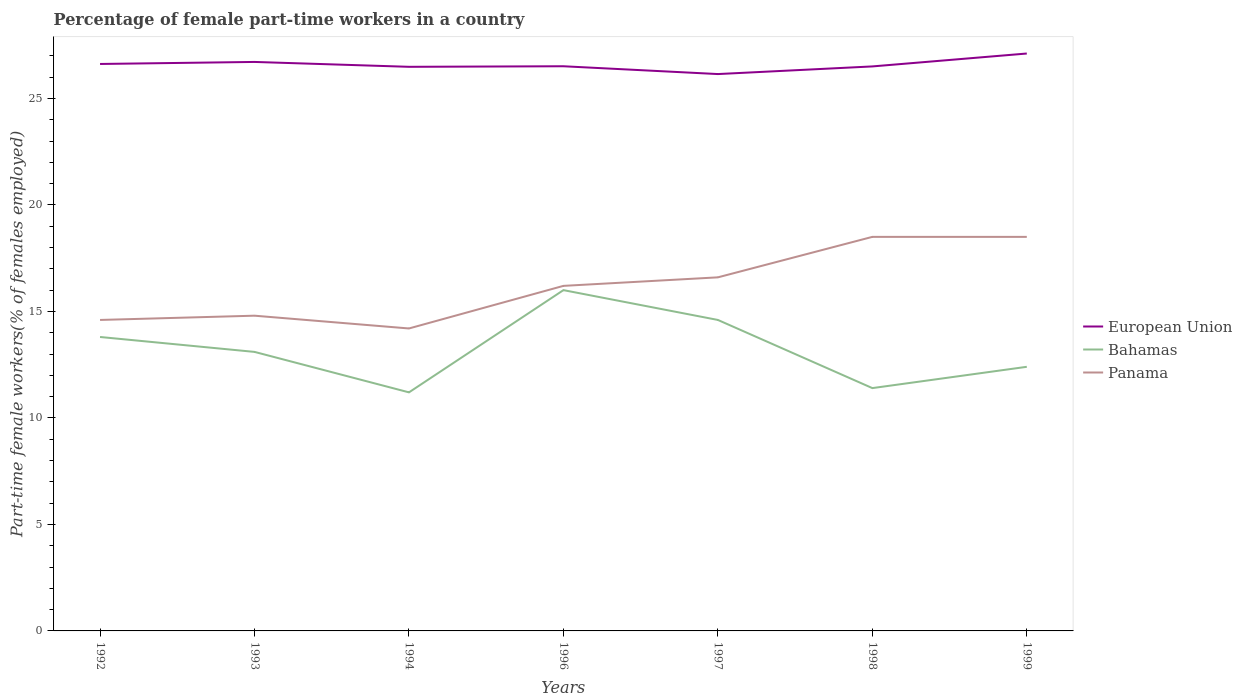How many different coloured lines are there?
Your response must be concise. 3. Across all years, what is the maximum percentage of female part-time workers in European Union?
Your answer should be compact. 26.14. What is the total percentage of female part-time workers in Panama in the graph?
Ensure brevity in your answer.  0.6. What is the difference between the highest and the second highest percentage of female part-time workers in Bahamas?
Offer a very short reply. 4.8. Is the percentage of female part-time workers in European Union strictly greater than the percentage of female part-time workers in Bahamas over the years?
Provide a short and direct response. No. How many lines are there?
Provide a succinct answer. 3. What is the difference between two consecutive major ticks on the Y-axis?
Offer a terse response. 5. Are the values on the major ticks of Y-axis written in scientific E-notation?
Provide a succinct answer. No. Does the graph contain any zero values?
Keep it short and to the point. No. Where does the legend appear in the graph?
Your answer should be very brief. Center right. How many legend labels are there?
Your response must be concise. 3. What is the title of the graph?
Offer a terse response. Percentage of female part-time workers in a country. What is the label or title of the X-axis?
Offer a very short reply. Years. What is the label or title of the Y-axis?
Your answer should be compact. Part-time female workers(% of females employed). What is the Part-time female workers(% of females employed) of European Union in 1992?
Provide a succinct answer. 26.62. What is the Part-time female workers(% of females employed) of Bahamas in 1992?
Offer a terse response. 13.8. What is the Part-time female workers(% of females employed) in Panama in 1992?
Provide a succinct answer. 14.6. What is the Part-time female workers(% of females employed) in European Union in 1993?
Make the answer very short. 26.71. What is the Part-time female workers(% of females employed) in Bahamas in 1993?
Your answer should be very brief. 13.1. What is the Part-time female workers(% of females employed) in Panama in 1993?
Your answer should be compact. 14.8. What is the Part-time female workers(% of females employed) in European Union in 1994?
Offer a very short reply. 26.48. What is the Part-time female workers(% of females employed) in Bahamas in 1994?
Give a very brief answer. 11.2. What is the Part-time female workers(% of females employed) in Panama in 1994?
Make the answer very short. 14.2. What is the Part-time female workers(% of females employed) of European Union in 1996?
Give a very brief answer. 26.51. What is the Part-time female workers(% of females employed) in Bahamas in 1996?
Your answer should be very brief. 16. What is the Part-time female workers(% of females employed) in Panama in 1996?
Provide a short and direct response. 16.2. What is the Part-time female workers(% of females employed) in European Union in 1997?
Offer a very short reply. 26.14. What is the Part-time female workers(% of females employed) in Bahamas in 1997?
Offer a terse response. 14.6. What is the Part-time female workers(% of females employed) in Panama in 1997?
Provide a succinct answer. 16.6. What is the Part-time female workers(% of females employed) of European Union in 1998?
Your answer should be compact. 26.5. What is the Part-time female workers(% of females employed) in Bahamas in 1998?
Your answer should be very brief. 11.4. What is the Part-time female workers(% of females employed) of European Union in 1999?
Offer a terse response. 27.11. What is the Part-time female workers(% of females employed) in Bahamas in 1999?
Give a very brief answer. 12.4. Across all years, what is the maximum Part-time female workers(% of females employed) in European Union?
Your response must be concise. 27.11. Across all years, what is the maximum Part-time female workers(% of females employed) of Panama?
Give a very brief answer. 18.5. Across all years, what is the minimum Part-time female workers(% of females employed) of European Union?
Ensure brevity in your answer.  26.14. Across all years, what is the minimum Part-time female workers(% of females employed) in Bahamas?
Your answer should be compact. 11.2. Across all years, what is the minimum Part-time female workers(% of females employed) of Panama?
Offer a terse response. 14.2. What is the total Part-time female workers(% of females employed) of European Union in the graph?
Give a very brief answer. 186.08. What is the total Part-time female workers(% of females employed) of Bahamas in the graph?
Keep it short and to the point. 92.5. What is the total Part-time female workers(% of females employed) in Panama in the graph?
Give a very brief answer. 113.4. What is the difference between the Part-time female workers(% of females employed) of European Union in 1992 and that in 1993?
Provide a short and direct response. -0.1. What is the difference between the Part-time female workers(% of females employed) in Bahamas in 1992 and that in 1993?
Provide a short and direct response. 0.7. What is the difference between the Part-time female workers(% of females employed) in European Union in 1992 and that in 1994?
Keep it short and to the point. 0.13. What is the difference between the Part-time female workers(% of females employed) in Bahamas in 1992 and that in 1994?
Offer a very short reply. 2.6. What is the difference between the Part-time female workers(% of females employed) of Panama in 1992 and that in 1994?
Your answer should be very brief. 0.4. What is the difference between the Part-time female workers(% of females employed) in European Union in 1992 and that in 1996?
Offer a very short reply. 0.11. What is the difference between the Part-time female workers(% of females employed) of European Union in 1992 and that in 1997?
Give a very brief answer. 0.47. What is the difference between the Part-time female workers(% of females employed) of Bahamas in 1992 and that in 1997?
Keep it short and to the point. -0.8. What is the difference between the Part-time female workers(% of females employed) in Panama in 1992 and that in 1997?
Your response must be concise. -2. What is the difference between the Part-time female workers(% of females employed) in European Union in 1992 and that in 1998?
Give a very brief answer. 0.12. What is the difference between the Part-time female workers(% of females employed) of Panama in 1992 and that in 1998?
Keep it short and to the point. -3.9. What is the difference between the Part-time female workers(% of females employed) in European Union in 1992 and that in 1999?
Your answer should be compact. -0.49. What is the difference between the Part-time female workers(% of females employed) of Bahamas in 1992 and that in 1999?
Your response must be concise. 1.4. What is the difference between the Part-time female workers(% of females employed) of European Union in 1993 and that in 1994?
Offer a very short reply. 0.23. What is the difference between the Part-time female workers(% of females employed) in European Union in 1993 and that in 1996?
Make the answer very short. 0.2. What is the difference between the Part-time female workers(% of females employed) of Bahamas in 1993 and that in 1996?
Make the answer very short. -2.9. What is the difference between the Part-time female workers(% of females employed) in European Union in 1993 and that in 1997?
Your answer should be compact. 0.57. What is the difference between the Part-time female workers(% of females employed) of European Union in 1993 and that in 1998?
Your answer should be very brief. 0.21. What is the difference between the Part-time female workers(% of females employed) in Panama in 1993 and that in 1998?
Give a very brief answer. -3.7. What is the difference between the Part-time female workers(% of females employed) in European Union in 1993 and that in 1999?
Your answer should be compact. -0.4. What is the difference between the Part-time female workers(% of females employed) of European Union in 1994 and that in 1996?
Your response must be concise. -0.03. What is the difference between the Part-time female workers(% of females employed) of European Union in 1994 and that in 1997?
Give a very brief answer. 0.34. What is the difference between the Part-time female workers(% of females employed) of Panama in 1994 and that in 1997?
Keep it short and to the point. -2.4. What is the difference between the Part-time female workers(% of females employed) in European Union in 1994 and that in 1998?
Your answer should be very brief. -0.02. What is the difference between the Part-time female workers(% of females employed) in Bahamas in 1994 and that in 1998?
Offer a very short reply. -0.2. What is the difference between the Part-time female workers(% of females employed) in European Union in 1994 and that in 1999?
Provide a succinct answer. -0.62. What is the difference between the Part-time female workers(% of females employed) in European Union in 1996 and that in 1997?
Make the answer very short. 0.37. What is the difference between the Part-time female workers(% of females employed) of Bahamas in 1996 and that in 1997?
Ensure brevity in your answer.  1.4. What is the difference between the Part-time female workers(% of females employed) in Panama in 1996 and that in 1997?
Your answer should be compact. -0.4. What is the difference between the Part-time female workers(% of females employed) in European Union in 1996 and that in 1998?
Your answer should be very brief. 0.01. What is the difference between the Part-time female workers(% of females employed) in European Union in 1996 and that in 1999?
Keep it short and to the point. -0.6. What is the difference between the Part-time female workers(% of females employed) in Bahamas in 1996 and that in 1999?
Keep it short and to the point. 3.6. What is the difference between the Part-time female workers(% of females employed) in European Union in 1997 and that in 1998?
Your answer should be compact. -0.36. What is the difference between the Part-time female workers(% of females employed) of Bahamas in 1997 and that in 1998?
Your answer should be compact. 3.2. What is the difference between the Part-time female workers(% of females employed) of Panama in 1997 and that in 1998?
Keep it short and to the point. -1.9. What is the difference between the Part-time female workers(% of females employed) in European Union in 1997 and that in 1999?
Make the answer very short. -0.96. What is the difference between the Part-time female workers(% of females employed) of Bahamas in 1997 and that in 1999?
Your answer should be compact. 2.2. What is the difference between the Part-time female workers(% of females employed) of European Union in 1998 and that in 1999?
Offer a terse response. -0.61. What is the difference between the Part-time female workers(% of females employed) of Panama in 1998 and that in 1999?
Offer a terse response. 0. What is the difference between the Part-time female workers(% of females employed) of European Union in 1992 and the Part-time female workers(% of females employed) of Bahamas in 1993?
Make the answer very short. 13.52. What is the difference between the Part-time female workers(% of females employed) in European Union in 1992 and the Part-time female workers(% of females employed) in Panama in 1993?
Give a very brief answer. 11.82. What is the difference between the Part-time female workers(% of females employed) in Bahamas in 1992 and the Part-time female workers(% of females employed) in Panama in 1993?
Provide a short and direct response. -1. What is the difference between the Part-time female workers(% of females employed) in European Union in 1992 and the Part-time female workers(% of females employed) in Bahamas in 1994?
Your answer should be very brief. 15.42. What is the difference between the Part-time female workers(% of females employed) in European Union in 1992 and the Part-time female workers(% of females employed) in Panama in 1994?
Keep it short and to the point. 12.42. What is the difference between the Part-time female workers(% of females employed) of European Union in 1992 and the Part-time female workers(% of females employed) of Bahamas in 1996?
Provide a short and direct response. 10.62. What is the difference between the Part-time female workers(% of females employed) of European Union in 1992 and the Part-time female workers(% of females employed) of Panama in 1996?
Your answer should be compact. 10.42. What is the difference between the Part-time female workers(% of females employed) in European Union in 1992 and the Part-time female workers(% of females employed) in Bahamas in 1997?
Ensure brevity in your answer.  12.02. What is the difference between the Part-time female workers(% of females employed) of European Union in 1992 and the Part-time female workers(% of females employed) of Panama in 1997?
Offer a very short reply. 10.02. What is the difference between the Part-time female workers(% of females employed) in European Union in 1992 and the Part-time female workers(% of females employed) in Bahamas in 1998?
Your answer should be compact. 15.22. What is the difference between the Part-time female workers(% of females employed) of European Union in 1992 and the Part-time female workers(% of females employed) of Panama in 1998?
Your answer should be very brief. 8.12. What is the difference between the Part-time female workers(% of females employed) of Bahamas in 1992 and the Part-time female workers(% of females employed) of Panama in 1998?
Your answer should be compact. -4.7. What is the difference between the Part-time female workers(% of females employed) of European Union in 1992 and the Part-time female workers(% of females employed) of Bahamas in 1999?
Your answer should be very brief. 14.22. What is the difference between the Part-time female workers(% of females employed) of European Union in 1992 and the Part-time female workers(% of females employed) of Panama in 1999?
Offer a terse response. 8.12. What is the difference between the Part-time female workers(% of females employed) of Bahamas in 1992 and the Part-time female workers(% of females employed) of Panama in 1999?
Offer a terse response. -4.7. What is the difference between the Part-time female workers(% of females employed) in European Union in 1993 and the Part-time female workers(% of females employed) in Bahamas in 1994?
Provide a succinct answer. 15.51. What is the difference between the Part-time female workers(% of females employed) of European Union in 1993 and the Part-time female workers(% of females employed) of Panama in 1994?
Your response must be concise. 12.51. What is the difference between the Part-time female workers(% of females employed) of Bahamas in 1993 and the Part-time female workers(% of females employed) of Panama in 1994?
Your answer should be very brief. -1.1. What is the difference between the Part-time female workers(% of females employed) in European Union in 1993 and the Part-time female workers(% of females employed) in Bahamas in 1996?
Your answer should be very brief. 10.71. What is the difference between the Part-time female workers(% of females employed) of European Union in 1993 and the Part-time female workers(% of females employed) of Panama in 1996?
Your answer should be very brief. 10.51. What is the difference between the Part-time female workers(% of females employed) in European Union in 1993 and the Part-time female workers(% of females employed) in Bahamas in 1997?
Ensure brevity in your answer.  12.11. What is the difference between the Part-time female workers(% of females employed) of European Union in 1993 and the Part-time female workers(% of females employed) of Panama in 1997?
Give a very brief answer. 10.11. What is the difference between the Part-time female workers(% of females employed) in European Union in 1993 and the Part-time female workers(% of females employed) in Bahamas in 1998?
Offer a very short reply. 15.31. What is the difference between the Part-time female workers(% of females employed) in European Union in 1993 and the Part-time female workers(% of females employed) in Panama in 1998?
Ensure brevity in your answer.  8.21. What is the difference between the Part-time female workers(% of females employed) in Bahamas in 1993 and the Part-time female workers(% of females employed) in Panama in 1998?
Your response must be concise. -5.4. What is the difference between the Part-time female workers(% of females employed) in European Union in 1993 and the Part-time female workers(% of females employed) in Bahamas in 1999?
Give a very brief answer. 14.31. What is the difference between the Part-time female workers(% of females employed) in European Union in 1993 and the Part-time female workers(% of females employed) in Panama in 1999?
Your response must be concise. 8.21. What is the difference between the Part-time female workers(% of females employed) of European Union in 1994 and the Part-time female workers(% of females employed) of Bahamas in 1996?
Your answer should be compact. 10.48. What is the difference between the Part-time female workers(% of females employed) of European Union in 1994 and the Part-time female workers(% of females employed) of Panama in 1996?
Keep it short and to the point. 10.28. What is the difference between the Part-time female workers(% of females employed) in European Union in 1994 and the Part-time female workers(% of females employed) in Bahamas in 1997?
Provide a succinct answer. 11.88. What is the difference between the Part-time female workers(% of females employed) in European Union in 1994 and the Part-time female workers(% of females employed) in Panama in 1997?
Make the answer very short. 9.88. What is the difference between the Part-time female workers(% of females employed) in Bahamas in 1994 and the Part-time female workers(% of females employed) in Panama in 1997?
Your response must be concise. -5.4. What is the difference between the Part-time female workers(% of females employed) of European Union in 1994 and the Part-time female workers(% of females employed) of Bahamas in 1998?
Offer a terse response. 15.08. What is the difference between the Part-time female workers(% of females employed) in European Union in 1994 and the Part-time female workers(% of females employed) in Panama in 1998?
Your answer should be very brief. 7.98. What is the difference between the Part-time female workers(% of females employed) of European Union in 1994 and the Part-time female workers(% of females employed) of Bahamas in 1999?
Keep it short and to the point. 14.08. What is the difference between the Part-time female workers(% of females employed) in European Union in 1994 and the Part-time female workers(% of females employed) in Panama in 1999?
Provide a short and direct response. 7.98. What is the difference between the Part-time female workers(% of females employed) in European Union in 1996 and the Part-time female workers(% of females employed) in Bahamas in 1997?
Offer a very short reply. 11.91. What is the difference between the Part-time female workers(% of females employed) in European Union in 1996 and the Part-time female workers(% of females employed) in Panama in 1997?
Give a very brief answer. 9.91. What is the difference between the Part-time female workers(% of females employed) of Bahamas in 1996 and the Part-time female workers(% of females employed) of Panama in 1997?
Ensure brevity in your answer.  -0.6. What is the difference between the Part-time female workers(% of females employed) of European Union in 1996 and the Part-time female workers(% of females employed) of Bahamas in 1998?
Your response must be concise. 15.11. What is the difference between the Part-time female workers(% of females employed) of European Union in 1996 and the Part-time female workers(% of females employed) of Panama in 1998?
Offer a very short reply. 8.01. What is the difference between the Part-time female workers(% of females employed) in European Union in 1996 and the Part-time female workers(% of females employed) in Bahamas in 1999?
Keep it short and to the point. 14.11. What is the difference between the Part-time female workers(% of females employed) of European Union in 1996 and the Part-time female workers(% of females employed) of Panama in 1999?
Provide a short and direct response. 8.01. What is the difference between the Part-time female workers(% of females employed) in European Union in 1997 and the Part-time female workers(% of females employed) in Bahamas in 1998?
Provide a succinct answer. 14.74. What is the difference between the Part-time female workers(% of females employed) of European Union in 1997 and the Part-time female workers(% of females employed) of Panama in 1998?
Give a very brief answer. 7.64. What is the difference between the Part-time female workers(% of females employed) in European Union in 1997 and the Part-time female workers(% of females employed) in Bahamas in 1999?
Keep it short and to the point. 13.74. What is the difference between the Part-time female workers(% of females employed) in European Union in 1997 and the Part-time female workers(% of females employed) in Panama in 1999?
Make the answer very short. 7.64. What is the difference between the Part-time female workers(% of females employed) in European Union in 1998 and the Part-time female workers(% of females employed) in Bahamas in 1999?
Make the answer very short. 14.1. What is the difference between the Part-time female workers(% of females employed) in European Union in 1998 and the Part-time female workers(% of females employed) in Panama in 1999?
Make the answer very short. 8. What is the average Part-time female workers(% of females employed) in European Union per year?
Offer a very short reply. 26.58. What is the average Part-time female workers(% of females employed) of Bahamas per year?
Offer a very short reply. 13.21. What is the average Part-time female workers(% of females employed) of Panama per year?
Keep it short and to the point. 16.2. In the year 1992, what is the difference between the Part-time female workers(% of females employed) in European Union and Part-time female workers(% of females employed) in Bahamas?
Provide a short and direct response. 12.82. In the year 1992, what is the difference between the Part-time female workers(% of females employed) of European Union and Part-time female workers(% of females employed) of Panama?
Ensure brevity in your answer.  12.02. In the year 1992, what is the difference between the Part-time female workers(% of females employed) of Bahamas and Part-time female workers(% of females employed) of Panama?
Provide a short and direct response. -0.8. In the year 1993, what is the difference between the Part-time female workers(% of females employed) of European Union and Part-time female workers(% of females employed) of Bahamas?
Give a very brief answer. 13.61. In the year 1993, what is the difference between the Part-time female workers(% of females employed) of European Union and Part-time female workers(% of females employed) of Panama?
Offer a terse response. 11.91. In the year 1994, what is the difference between the Part-time female workers(% of females employed) of European Union and Part-time female workers(% of females employed) of Bahamas?
Provide a succinct answer. 15.28. In the year 1994, what is the difference between the Part-time female workers(% of females employed) in European Union and Part-time female workers(% of females employed) in Panama?
Ensure brevity in your answer.  12.28. In the year 1996, what is the difference between the Part-time female workers(% of females employed) in European Union and Part-time female workers(% of females employed) in Bahamas?
Ensure brevity in your answer.  10.51. In the year 1996, what is the difference between the Part-time female workers(% of females employed) in European Union and Part-time female workers(% of females employed) in Panama?
Your answer should be very brief. 10.31. In the year 1996, what is the difference between the Part-time female workers(% of females employed) of Bahamas and Part-time female workers(% of females employed) of Panama?
Ensure brevity in your answer.  -0.2. In the year 1997, what is the difference between the Part-time female workers(% of females employed) of European Union and Part-time female workers(% of females employed) of Bahamas?
Ensure brevity in your answer.  11.54. In the year 1997, what is the difference between the Part-time female workers(% of females employed) in European Union and Part-time female workers(% of females employed) in Panama?
Offer a very short reply. 9.54. In the year 1997, what is the difference between the Part-time female workers(% of females employed) in Bahamas and Part-time female workers(% of females employed) in Panama?
Offer a very short reply. -2. In the year 1998, what is the difference between the Part-time female workers(% of females employed) of European Union and Part-time female workers(% of females employed) of Bahamas?
Offer a very short reply. 15.1. In the year 1998, what is the difference between the Part-time female workers(% of females employed) of European Union and Part-time female workers(% of females employed) of Panama?
Your response must be concise. 8. In the year 1999, what is the difference between the Part-time female workers(% of females employed) of European Union and Part-time female workers(% of females employed) of Bahamas?
Provide a succinct answer. 14.71. In the year 1999, what is the difference between the Part-time female workers(% of females employed) of European Union and Part-time female workers(% of females employed) of Panama?
Your answer should be very brief. 8.61. In the year 1999, what is the difference between the Part-time female workers(% of females employed) of Bahamas and Part-time female workers(% of females employed) of Panama?
Ensure brevity in your answer.  -6.1. What is the ratio of the Part-time female workers(% of females employed) in European Union in 1992 to that in 1993?
Give a very brief answer. 1. What is the ratio of the Part-time female workers(% of females employed) of Bahamas in 1992 to that in 1993?
Keep it short and to the point. 1.05. What is the ratio of the Part-time female workers(% of females employed) in Panama in 1992 to that in 1993?
Keep it short and to the point. 0.99. What is the ratio of the Part-time female workers(% of females employed) in Bahamas in 1992 to that in 1994?
Provide a succinct answer. 1.23. What is the ratio of the Part-time female workers(% of females employed) in Panama in 1992 to that in 1994?
Provide a succinct answer. 1.03. What is the ratio of the Part-time female workers(% of females employed) of Bahamas in 1992 to that in 1996?
Give a very brief answer. 0.86. What is the ratio of the Part-time female workers(% of females employed) in Panama in 1992 to that in 1996?
Your answer should be very brief. 0.9. What is the ratio of the Part-time female workers(% of females employed) of European Union in 1992 to that in 1997?
Ensure brevity in your answer.  1.02. What is the ratio of the Part-time female workers(% of females employed) of Bahamas in 1992 to that in 1997?
Your answer should be compact. 0.95. What is the ratio of the Part-time female workers(% of females employed) of Panama in 1992 to that in 1997?
Your answer should be compact. 0.88. What is the ratio of the Part-time female workers(% of females employed) of European Union in 1992 to that in 1998?
Offer a terse response. 1. What is the ratio of the Part-time female workers(% of females employed) of Bahamas in 1992 to that in 1998?
Provide a succinct answer. 1.21. What is the ratio of the Part-time female workers(% of females employed) in Panama in 1992 to that in 1998?
Your answer should be compact. 0.79. What is the ratio of the Part-time female workers(% of females employed) in European Union in 1992 to that in 1999?
Give a very brief answer. 0.98. What is the ratio of the Part-time female workers(% of females employed) of Bahamas in 1992 to that in 1999?
Provide a short and direct response. 1.11. What is the ratio of the Part-time female workers(% of females employed) in Panama in 1992 to that in 1999?
Your answer should be very brief. 0.79. What is the ratio of the Part-time female workers(% of females employed) of European Union in 1993 to that in 1994?
Your answer should be compact. 1.01. What is the ratio of the Part-time female workers(% of females employed) in Bahamas in 1993 to that in 1994?
Offer a very short reply. 1.17. What is the ratio of the Part-time female workers(% of females employed) in Panama in 1993 to that in 1994?
Give a very brief answer. 1.04. What is the ratio of the Part-time female workers(% of females employed) in European Union in 1993 to that in 1996?
Make the answer very short. 1.01. What is the ratio of the Part-time female workers(% of females employed) of Bahamas in 1993 to that in 1996?
Provide a short and direct response. 0.82. What is the ratio of the Part-time female workers(% of females employed) of Panama in 1993 to that in 1996?
Your answer should be compact. 0.91. What is the ratio of the Part-time female workers(% of females employed) of European Union in 1993 to that in 1997?
Ensure brevity in your answer.  1.02. What is the ratio of the Part-time female workers(% of females employed) in Bahamas in 1993 to that in 1997?
Your answer should be compact. 0.9. What is the ratio of the Part-time female workers(% of females employed) of Panama in 1993 to that in 1997?
Give a very brief answer. 0.89. What is the ratio of the Part-time female workers(% of females employed) in European Union in 1993 to that in 1998?
Provide a short and direct response. 1.01. What is the ratio of the Part-time female workers(% of females employed) in Bahamas in 1993 to that in 1998?
Give a very brief answer. 1.15. What is the ratio of the Part-time female workers(% of females employed) in European Union in 1993 to that in 1999?
Provide a succinct answer. 0.99. What is the ratio of the Part-time female workers(% of females employed) of Bahamas in 1993 to that in 1999?
Keep it short and to the point. 1.06. What is the ratio of the Part-time female workers(% of females employed) of Panama in 1993 to that in 1999?
Your answer should be compact. 0.8. What is the ratio of the Part-time female workers(% of females employed) of European Union in 1994 to that in 1996?
Give a very brief answer. 1. What is the ratio of the Part-time female workers(% of females employed) of Bahamas in 1994 to that in 1996?
Make the answer very short. 0.7. What is the ratio of the Part-time female workers(% of females employed) in Panama in 1994 to that in 1996?
Ensure brevity in your answer.  0.88. What is the ratio of the Part-time female workers(% of females employed) of Bahamas in 1994 to that in 1997?
Provide a succinct answer. 0.77. What is the ratio of the Part-time female workers(% of females employed) in Panama in 1994 to that in 1997?
Provide a short and direct response. 0.86. What is the ratio of the Part-time female workers(% of females employed) in European Union in 1994 to that in 1998?
Your response must be concise. 1. What is the ratio of the Part-time female workers(% of females employed) in Bahamas in 1994 to that in 1998?
Your answer should be compact. 0.98. What is the ratio of the Part-time female workers(% of females employed) of Panama in 1994 to that in 1998?
Keep it short and to the point. 0.77. What is the ratio of the Part-time female workers(% of females employed) of Bahamas in 1994 to that in 1999?
Your answer should be very brief. 0.9. What is the ratio of the Part-time female workers(% of females employed) of Panama in 1994 to that in 1999?
Your answer should be very brief. 0.77. What is the ratio of the Part-time female workers(% of females employed) of Bahamas in 1996 to that in 1997?
Offer a terse response. 1.1. What is the ratio of the Part-time female workers(% of females employed) in Panama in 1996 to that in 1997?
Ensure brevity in your answer.  0.98. What is the ratio of the Part-time female workers(% of females employed) of European Union in 1996 to that in 1998?
Your response must be concise. 1. What is the ratio of the Part-time female workers(% of females employed) of Bahamas in 1996 to that in 1998?
Keep it short and to the point. 1.4. What is the ratio of the Part-time female workers(% of females employed) of Panama in 1996 to that in 1998?
Keep it short and to the point. 0.88. What is the ratio of the Part-time female workers(% of females employed) of European Union in 1996 to that in 1999?
Give a very brief answer. 0.98. What is the ratio of the Part-time female workers(% of females employed) of Bahamas in 1996 to that in 1999?
Your answer should be compact. 1.29. What is the ratio of the Part-time female workers(% of females employed) of Panama in 1996 to that in 1999?
Offer a very short reply. 0.88. What is the ratio of the Part-time female workers(% of females employed) of European Union in 1997 to that in 1998?
Provide a short and direct response. 0.99. What is the ratio of the Part-time female workers(% of females employed) in Bahamas in 1997 to that in 1998?
Keep it short and to the point. 1.28. What is the ratio of the Part-time female workers(% of females employed) of Panama in 1997 to that in 1998?
Provide a succinct answer. 0.9. What is the ratio of the Part-time female workers(% of females employed) in European Union in 1997 to that in 1999?
Your answer should be very brief. 0.96. What is the ratio of the Part-time female workers(% of females employed) in Bahamas in 1997 to that in 1999?
Make the answer very short. 1.18. What is the ratio of the Part-time female workers(% of females employed) of Panama in 1997 to that in 1999?
Make the answer very short. 0.9. What is the ratio of the Part-time female workers(% of females employed) in European Union in 1998 to that in 1999?
Offer a terse response. 0.98. What is the ratio of the Part-time female workers(% of females employed) of Bahamas in 1998 to that in 1999?
Give a very brief answer. 0.92. What is the ratio of the Part-time female workers(% of females employed) in Panama in 1998 to that in 1999?
Your response must be concise. 1. What is the difference between the highest and the second highest Part-time female workers(% of females employed) in European Union?
Your answer should be very brief. 0.4. What is the difference between the highest and the lowest Part-time female workers(% of females employed) of European Union?
Give a very brief answer. 0.96. 